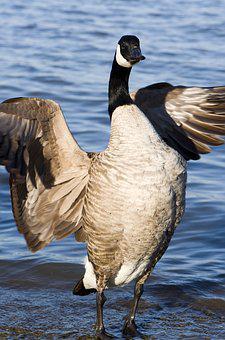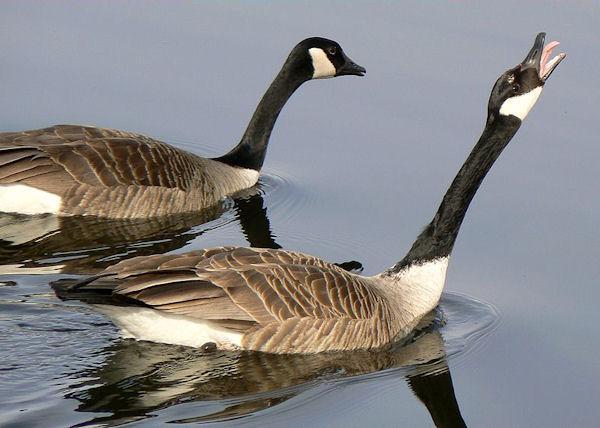The first image is the image on the left, the second image is the image on the right. Analyze the images presented: Is the assertion "More water fowl are shown in the right image." valid? Answer yes or no. Yes. 